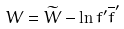Convert formula to latex. <formula><loc_0><loc_0><loc_500><loc_500>W = { \widetilde { W } } - \ln f ^ { \prime } { \overline { f } } ^ { \prime }</formula> 